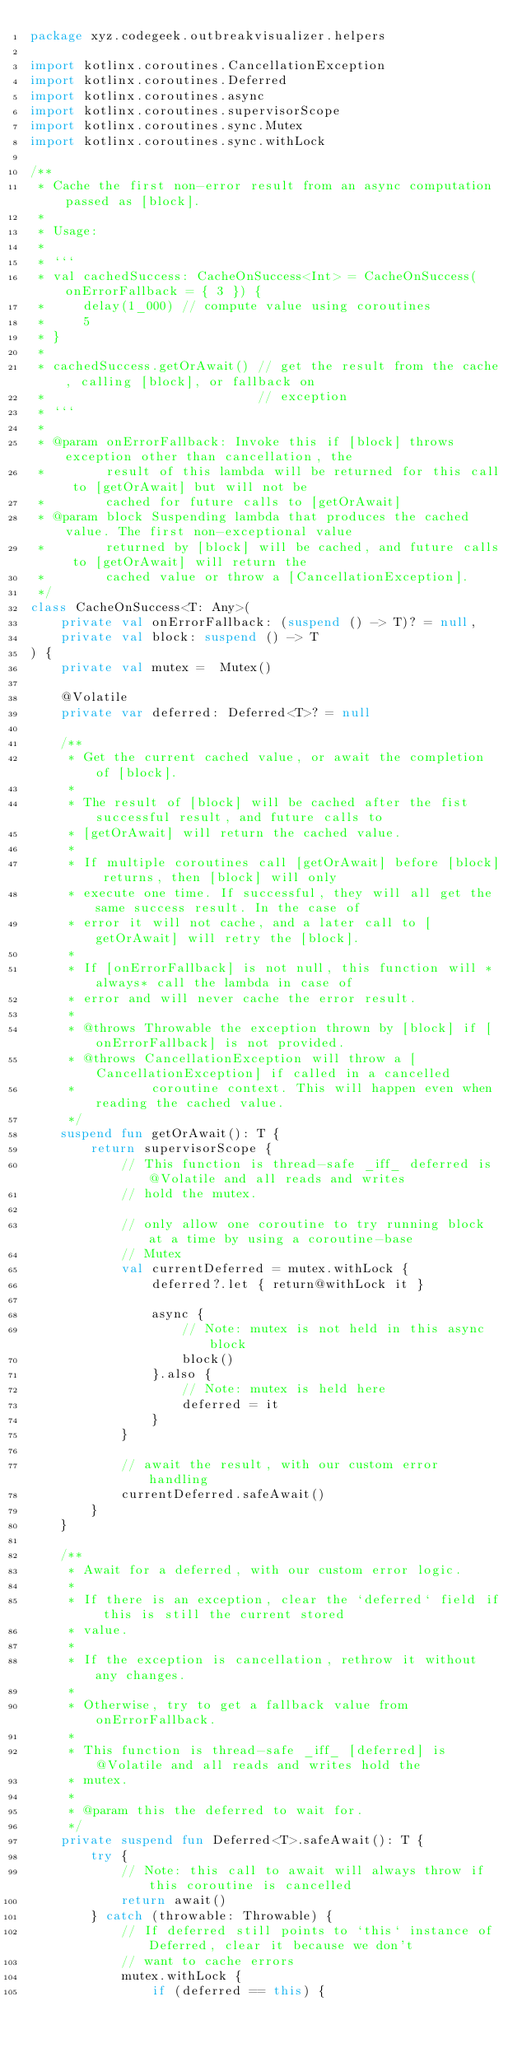Convert code to text. <code><loc_0><loc_0><loc_500><loc_500><_Kotlin_>package xyz.codegeek.outbreakvisualizer.helpers

import kotlinx.coroutines.CancellationException
import kotlinx.coroutines.Deferred
import kotlinx.coroutines.async
import kotlinx.coroutines.supervisorScope
import kotlinx.coroutines.sync.Mutex
import kotlinx.coroutines.sync.withLock

/**
 * Cache the first non-error result from an async computation passed as [block].
 *
 * Usage:
 *
 * ```
 * val cachedSuccess: CacheOnSuccess<Int> = CacheOnSuccess(onErrorFallback = { 3 }) {
 *     delay(1_000) // compute value using coroutines
 *     5
 * }
 *
 * cachedSuccess.getOrAwait() // get the result from the cache, calling [block], or fallback on
 *                            // exception
 * ```
 *
 * @param onErrorFallback: Invoke this if [block] throws exception other than cancellation, the
 *        result of this lambda will be returned for this call to [getOrAwait] but will not be
 *        cached for future calls to [getOrAwait]
 * @param block Suspending lambda that produces the cached value. The first non-exceptional value
 *        returned by [block] will be cached, and future calls to [getOrAwait] will return the
 *        cached value or throw a [CancellationException].
 */
class CacheOnSuccess<T: Any>(
    private val onErrorFallback: (suspend () -> T)? = null,
    private val block: suspend () -> T
) {
    private val mutex =  Mutex()

    @Volatile
    private var deferred: Deferred<T>? = null

    /**
     * Get the current cached value, or await the completion of [block].
     *
     * The result of [block] will be cached after the fist successful result, and future calls to
     * [getOrAwait] will return the cached value.
     *
     * If multiple coroutines call [getOrAwait] before [block] returns, then [block] will only
     * execute one time. If successful, they will all get the same success result. In the case of
     * error it will not cache, and a later call to [getOrAwait] will retry the [block].
     *
     * If [onErrorFallback] is not null, this function will *always* call the lambda in case of
     * error and will never cache the error result.
     *
     * @throws Throwable the exception thrown by [block] if [onErrorFallback] is not provided.
     * @throws CancellationException will throw a [CancellationException] if called in a cancelled
     *          coroutine context. This will happen even when reading the cached value.
     */
    suspend fun getOrAwait(): T {
        return supervisorScope {
            // This function is thread-safe _iff_ deferred is @Volatile and all reads and writes
            // hold the mutex.

            // only allow one coroutine to try running block at a time by using a coroutine-base
            // Mutex
            val currentDeferred = mutex.withLock {
                deferred?.let { return@withLock it }

                async {
                    // Note: mutex is not held in this async block
                    block()
                }.also {
                    // Note: mutex is held here
                    deferred = it
                }
            }

            // await the result, with our custom error handling
            currentDeferred.safeAwait()
        }
    }

    /**
     * Await for a deferred, with our custom error logic.
     *
     * If there is an exception, clear the `deferred` field if this is still the current stored
     * value.
     *
     * If the exception is cancellation, rethrow it without any changes.
     *
     * Otherwise, try to get a fallback value from onErrorFallback.
     *
     * This function is thread-safe _iff_ [deferred] is @Volatile and all reads and writes hold the
     * mutex.
     *
     * @param this the deferred to wait for.
     */
    private suspend fun Deferred<T>.safeAwait(): T {
        try {
            // Note: this call to await will always throw if this coroutine is cancelled
            return await()
        } catch (throwable: Throwable) {
            // If deferred still points to `this` instance of Deferred, clear it because we don't
            // want to cache errors
            mutex.withLock {
                if (deferred == this) {</code> 